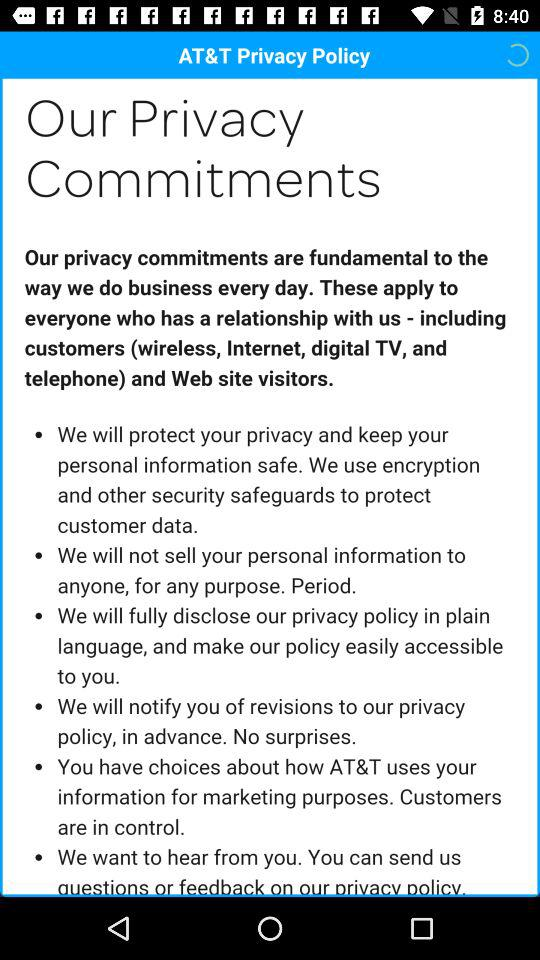To whom do the privacy commitments apply? The privacy commitments apply to everyone who has a relationship with us, including customers (wireless, Internet, digital TV, and telephone) and web site visitors. 